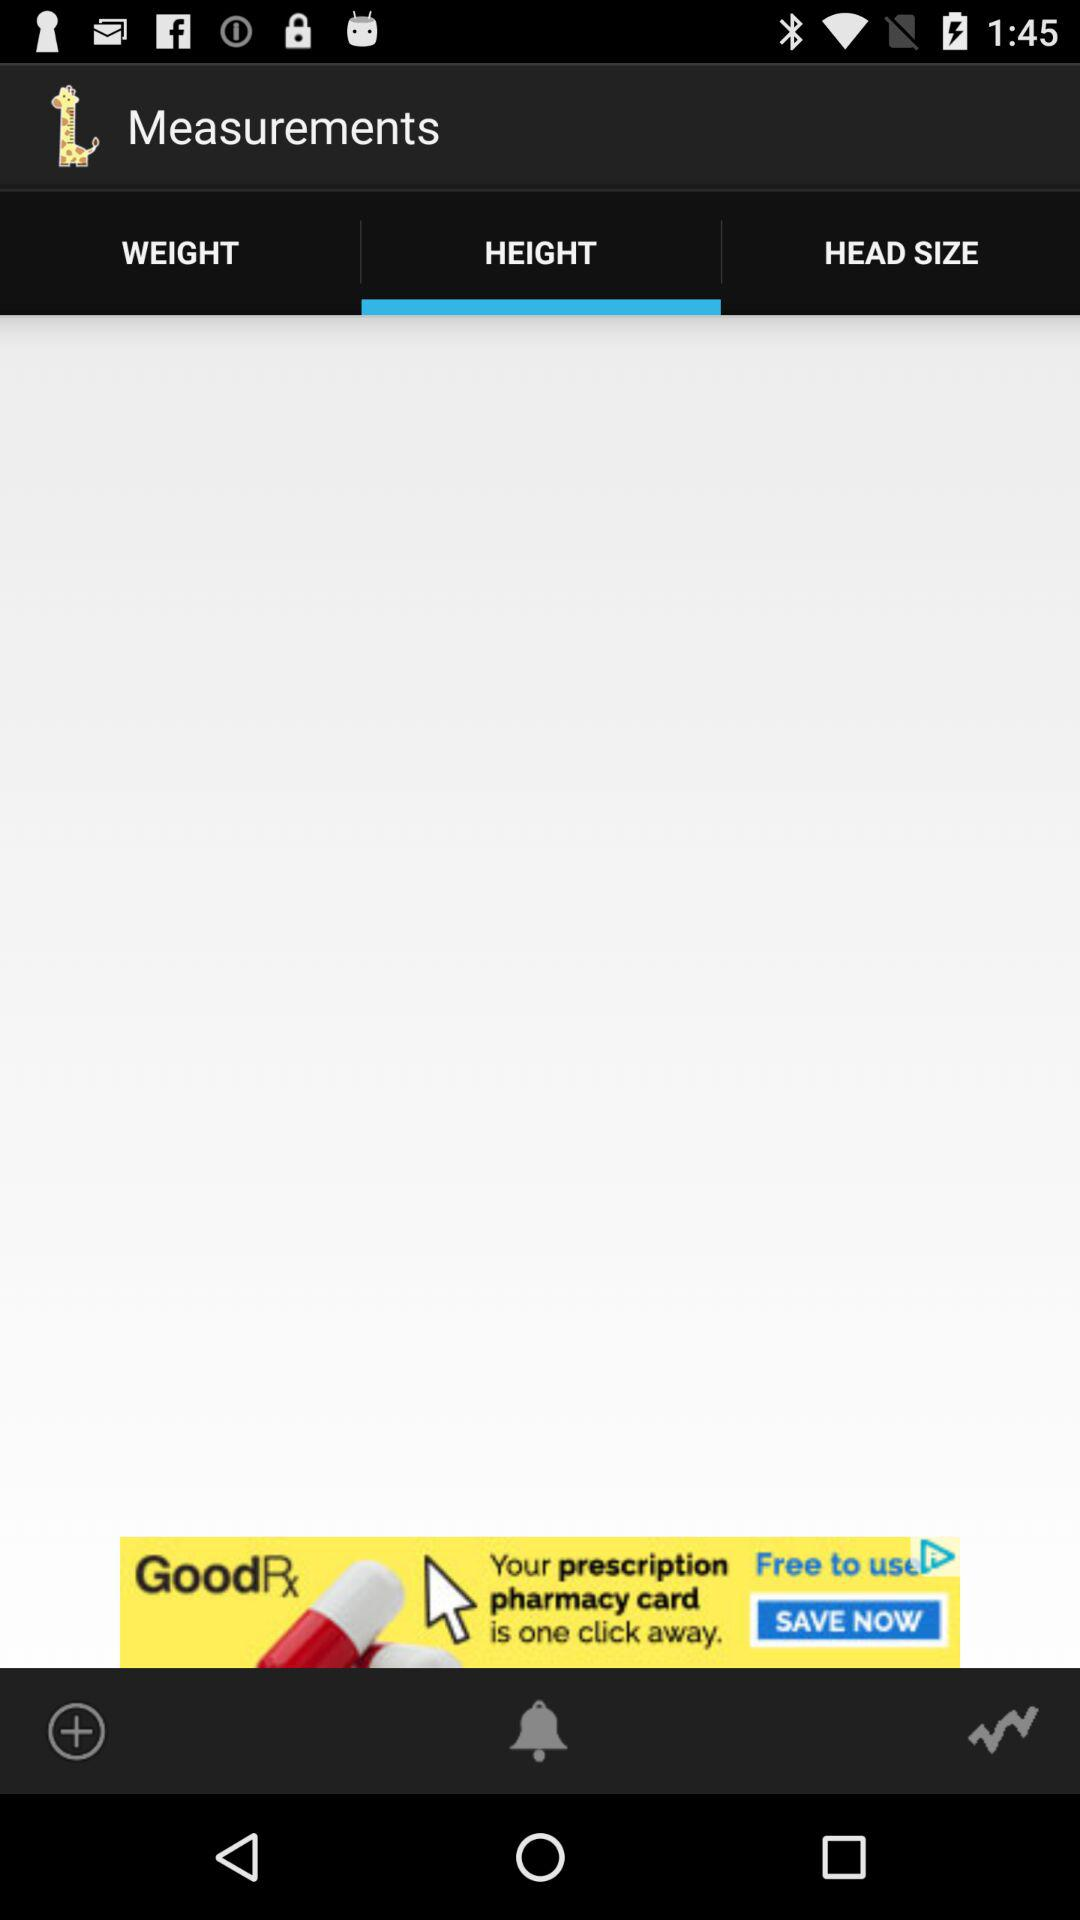What is the selected tab? The selected tab is "HEIGHT". 